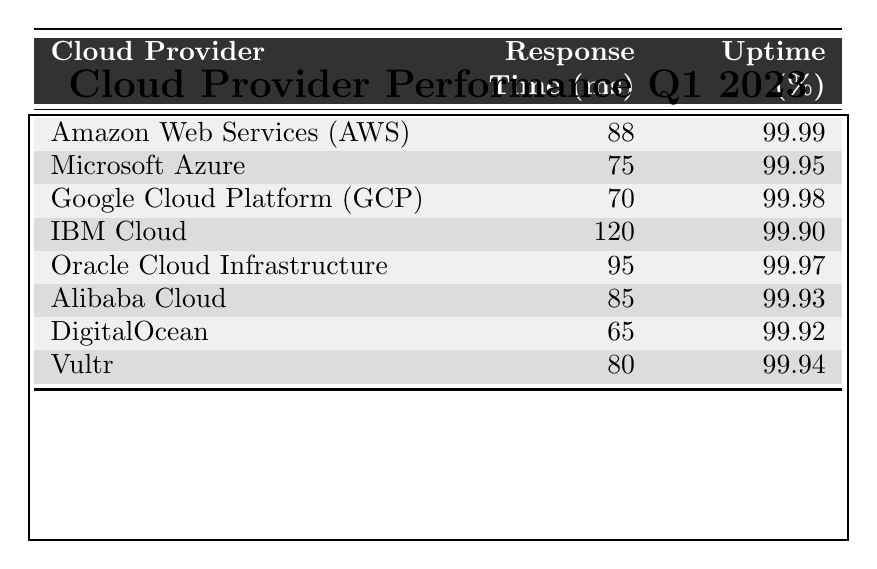What is the response time for Google Cloud Platform (GCP)? Looking at the table, the row for Google Cloud Platform (GCP) states that its response time is 70 milliseconds.
Answer: 70 ms Which cloud provider has the highest uptime percentage? The table shows the uptime percentages for all cloud providers, and Amazon Web Services (AWS) has the highest percentage at 99.99%.
Answer: 99.99% What is the difference in response time between IBM Cloud and DigitalOcean? From the table, IBM Cloud has a response time of 120 ms and DigitalOcean has 65 ms. The difference is calculated as 120 - 65 = 55 ms.
Answer: 55 ms Is the uptime percentage of Oracle Cloud Infrastructure greater than that of Alibaba Cloud? Oracle Cloud Infrastructure has an uptime of 99.97% and Alibaba Cloud has 99.93%. Since 99.97 is greater than 99.93, the answer is yes.
Answer: Yes What is the average response time of all listed cloud providers? First, we list the response times: 88, 75, 70, 120, 95, 85, 65, 80. The sum is 88 + 75 + 70 + 120 + 95 + 85 + 65 + 80 = 778 ms. There are 8 providers, so the average is 778 / 8 = 97.25 ms.
Answer: 97.25 ms How many cloud providers have a response time less than 90 ms? Checking the response times, those less than 90 ms are: Microsoft Azure (75), Google Cloud Platform (70), DigitalOcean (65), and Vultr (80), totaling 4 providers.
Answer: 4 Which cloud provider has the lowest response time and what is it? By reviewing the response times in the table, DigitalOcean has the lowest response time at 65 ms.
Answer: DigitalOcean, 65 ms What is the total uptime percentage of all the cloud providers? The uptime percentages are: 99.99, 99.95, 99.98, 99.90, 99.97, 99.93, 99.92, and 99.94. Adding them all yields 799.88. This isn't a valid measure to average, as the percentage does not have a cumulative total that makes sense.
Answer: N/A Which cloud provider has the second-best response time and what is it? By ordering response times, Google Cloud Platform (GCP) has the second-best at 70 ms, following DigitalOcean at 65 ms.
Answer: Google Cloud Platform, 70 ms Does Microsoft Azure have a higher uptime percentage than IBM Cloud? Microsoft Azure has an uptime of 99.95% while IBM Cloud has 99.90%. Since 99.95 is greater than 99.90, the answer is yes.
Answer: Yes 